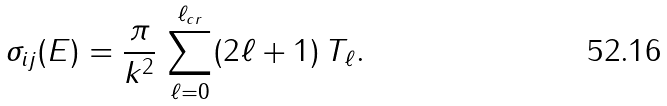Convert formula to latex. <formula><loc_0><loc_0><loc_500><loc_500>\sigma _ { i j } ( E ) = \frac { \pi } { k ^ { 2 } } \, \sum _ { \ell = 0 } ^ { \ell _ { c r } } ( 2 \ell + 1 ) \, T _ { \ell } .</formula> 